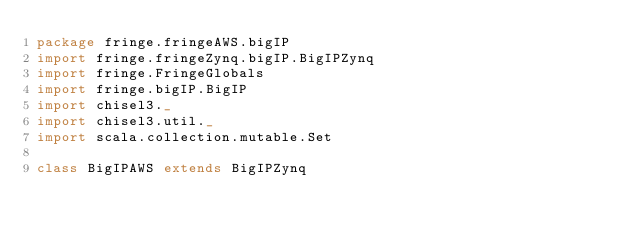Convert code to text. <code><loc_0><loc_0><loc_500><loc_500><_Scala_>package fringe.fringeAWS.bigIP
import fringe.fringeZynq.bigIP.BigIPZynq
import fringe.FringeGlobals
import fringe.bigIP.BigIP
import chisel3._
import chisel3.util._
import scala.collection.mutable.Set

class BigIPAWS extends BigIPZynq
</code> 